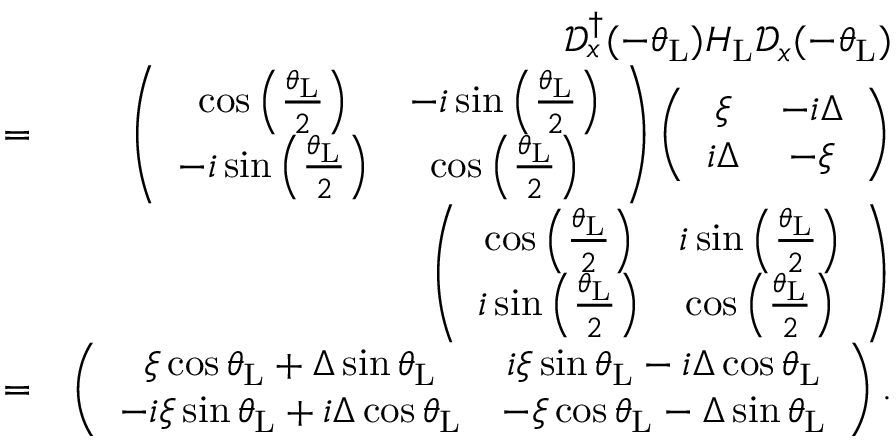Convert formula to latex. <formula><loc_0><loc_0><loc_500><loc_500>\begin{array} { r l r } & { \mathcal { D } _ { x } ^ { \dagger } ( - \theta _ { L } ) H _ { L } \mathcal { D } _ { x } ( - \theta _ { L } ) } \\ & { = } & { \left ( \begin{array} { c c } { \cos \left ( \frac { \theta _ { L } } { 2 } \right ) } & { - i \sin \left ( \frac { \theta _ { L } } { 2 } \right ) } \\ { - i \sin \left ( \frac { \theta _ { L } } { 2 } \right ) } & { \cos \left ( \frac { \theta _ { L } } { 2 } \right ) } \end{array} \right ) \left ( \begin{array} { c c } { \xi } & { - i \Delta } \\ { i \Delta } & { - \xi } \end{array} \right ) } \\ & { \left ( \begin{array} { c c } { \cos \left ( \frac { \theta _ { L } } { 2 } \right ) } & { i \sin \left ( \frac { \theta _ { L } } { 2 } \right ) } \\ { i \sin \left ( \frac { \theta _ { L } } { 2 } \right ) } & { \cos \left ( \frac { \theta _ { L } } { 2 } \right ) } \end{array} \right ) } \\ & { = } & { \left ( \begin{array} { c c } { \xi \cos \theta _ { L } + \Delta \sin \theta _ { L } } & { i \xi \sin \theta _ { L } - i \Delta \cos \theta _ { L } } \\ { - i \xi \sin \theta _ { L } + i \Delta \cos \theta _ { L } } & { - \xi \cos \theta _ { L } - \Delta \sin \theta _ { L } } \end{array} \right ) . } \end{array}</formula> 